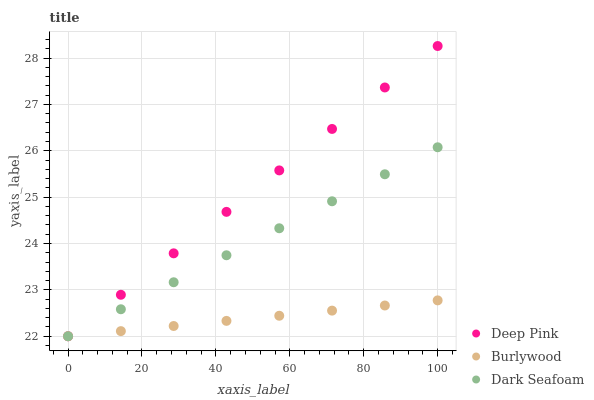Does Burlywood have the minimum area under the curve?
Answer yes or no. Yes. Does Deep Pink have the maximum area under the curve?
Answer yes or no. Yes. Does Dark Seafoam have the minimum area under the curve?
Answer yes or no. No. Does Dark Seafoam have the maximum area under the curve?
Answer yes or no. No. Is Burlywood the smoothest?
Answer yes or no. Yes. Is Deep Pink the roughest?
Answer yes or no. Yes. Is Dark Seafoam the smoothest?
Answer yes or no. No. Is Dark Seafoam the roughest?
Answer yes or no. No. Does Burlywood have the lowest value?
Answer yes or no. Yes. Does Deep Pink have the highest value?
Answer yes or no. Yes. Does Dark Seafoam have the highest value?
Answer yes or no. No. Does Dark Seafoam intersect Deep Pink?
Answer yes or no. Yes. Is Dark Seafoam less than Deep Pink?
Answer yes or no. No. Is Dark Seafoam greater than Deep Pink?
Answer yes or no. No. 